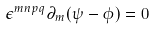Convert formula to latex. <formula><loc_0><loc_0><loc_500><loc_500>\epsilon ^ { m n p q } \partial _ { m } ( \psi - \phi ) = 0</formula> 